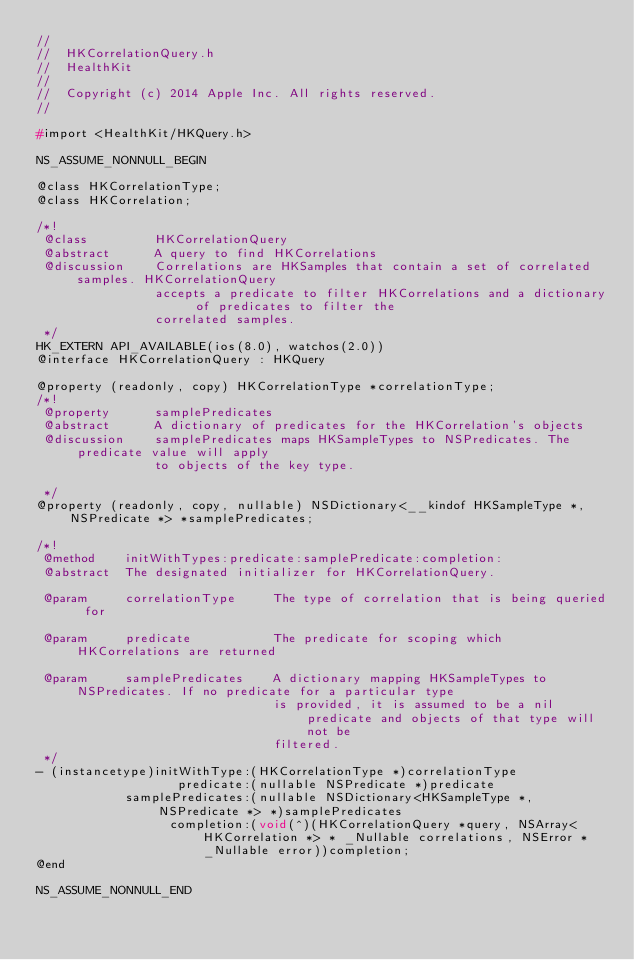Convert code to text. <code><loc_0><loc_0><loc_500><loc_500><_C_>//
//  HKCorrelationQuery.h
//  HealthKit
//
//  Copyright (c) 2014 Apple Inc. All rights reserved.
//

#import <HealthKit/HKQuery.h>

NS_ASSUME_NONNULL_BEGIN

@class HKCorrelationType;
@class HKCorrelation;

/*!
 @class         HKCorrelationQuery
 @abstract      A query to find HKCorrelations
 @discussion    Correlations are HKSamples that contain a set of correlated samples. HKCorrelationQuery
                accepts a predicate to filter HKCorrelations and a dictionary of predicates to filter the
                correlated samples.
 */
HK_EXTERN API_AVAILABLE(ios(8.0), watchos(2.0))
@interface HKCorrelationQuery : HKQuery

@property (readonly, copy) HKCorrelationType *correlationType;
/*!
 @property      samplePredicates
 @abstract      A dictionary of predicates for the HKCorrelation's objects
 @discussion    samplePredicates maps HKSampleTypes to NSPredicates. The predicate value will apply
                to objects of the key type. 
 
 */
@property (readonly, copy, nullable) NSDictionary<__kindof HKSampleType *, NSPredicate *> *samplePredicates;

/*!
 @method    initWithTypes:predicate:samplePredicate:completion:
 @abstract  The designated initializer for HKCorrelationQuery.

 @param     correlationType     The type of correlation that is being queried for

 @param     predicate           The predicate for scoping which HKCorrelations are returned

 @param     samplePredicates    A dictionary mapping HKSampleTypes to NSPredicates. If no predicate for a particular type
                                is provided, it is assumed to be a nil predicate and objects of that type will not be
                                filtered.
 */
- (instancetype)initWithType:(HKCorrelationType *)correlationType
                   predicate:(nullable NSPredicate *)predicate
            samplePredicates:(nullable NSDictionary<HKSampleType *, NSPredicate *> *)samplePredicates
                  completion:(void(^)(HKCorrelationQuery *query, NSArray<HKCorrelation *> * _Nullable correlations, NSError * _Nullable error))completion;
@end

NS_ASSUME_NONNULL_END
</code> 